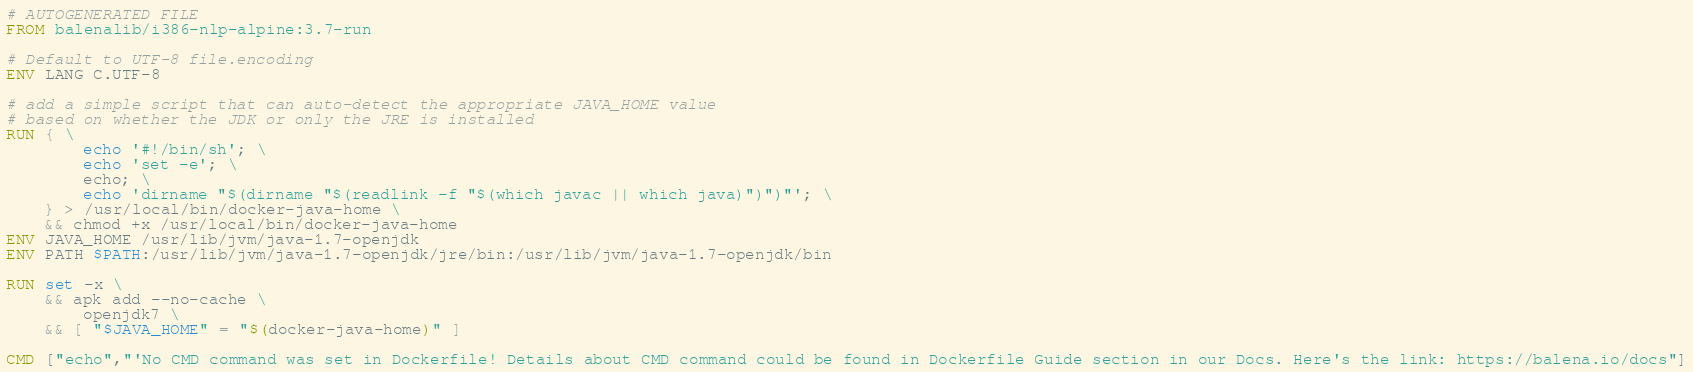<code> <loc_0><loc_0><loc_500><loc_500><_Dockerfile_># AUTOGENERATED FILE
FROM balenalib/i386-nlp-alpine:3.7-run

# Default to UTF-8 file.encoding
ENV LANG C.UTF-8

# add a simple script that can auto-detect the appropriate JAVA_HOME value
# based on whether the JDK or only the JRE is installed
RUN { \
		echo '#!/bin/sh'; \
		echo 'set -e'; \
		echo; \
		echo 'dirname "$(dirname "$(readlink -f "$(which javac || which java)")")"'; \
	} > /usr/local/bin/docker-java-home \
	&& chmod +x /usr/local/bin/docker-java-home
ENV JAVA_HOME /usr/lib/jvm/java-1.7-openjdk
ENV PATH $PATH:/usr/lib/jvm/java-1.7-openjdk/jre/bin:/usr/lib/jvm/java-1.7-openjdk/bin

RUN set -x \
	&& apk add --no-cache \
		openjdk7 \
	&& [ "$JAVA_HOME" = "$(docker-java-home)" ]

CMD ["echo","'No CMD command was set in Dockerfile! Details about CMD command could be found in Dockerfile Guide section in our Docs. Here's the link: https://balena.io/docs"]</code> 